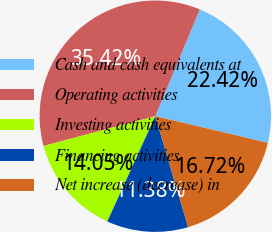<chart> <loc_0><loc_0><loc_500><loc_500><pie_chart><fcel>Cash and cash equivalents at<fcel>Operating activities<fcel>Investing activities<fcel>Financing activities<fcel>Net increase (decrease) in<nl><fcel>22.42%<fcel>35.42%<fcel>14.05%<fcel>11.38%<fcel>16.72%<nl></chart> 